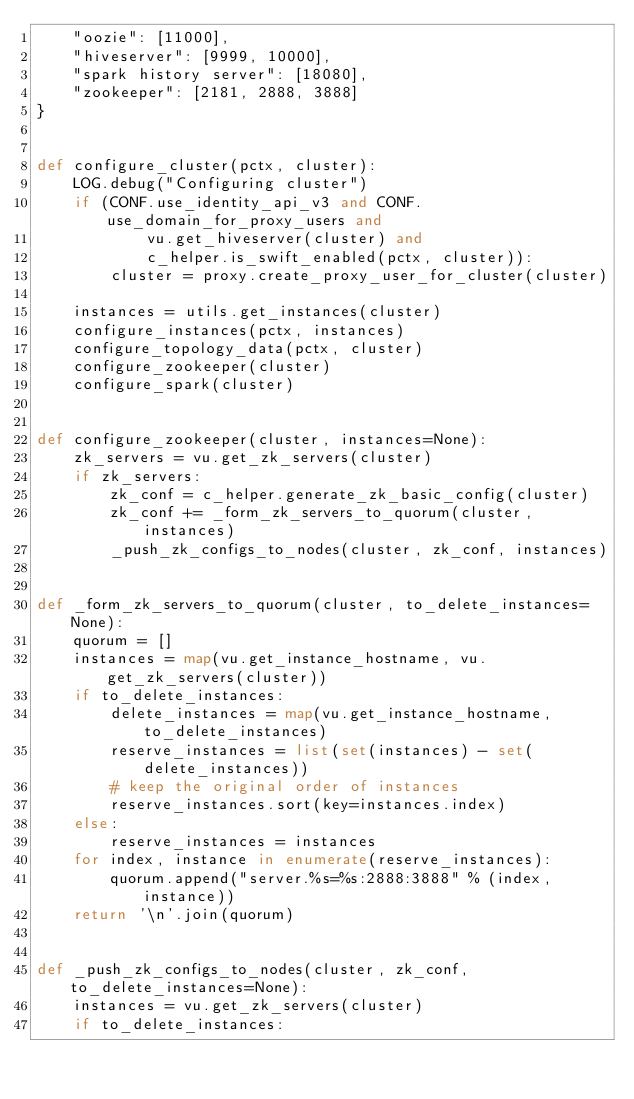Convert code to text. <code><loc_0><loc_0><loc_500><loc_500><_Python_>    "oozie": [11000],
    "hiveserver": [9999, 10000],
    "spark history server": [18080],
    "zookeeper": [2181, 2888, 3888]
}


def configure_cluster(pctx, cluster):
    LOG.debug("Configuring cluster")
    if (CONF.use_identity_api_v3 and CONF.use_domain_for_proxy_users and
            vu.get_hiveserver(cluster) and
            c_helper.is_swift_enabled(pctx, cluster)):
        cluster = proxy.create_proxy_user_for_cluster(cluster)

    instances = utils.get_instances(cluster)
    configure_instances(pctx, instances)
    configure_topology_data(pctx, cluster)
    configure_zookeeper(cluster)
    configure_spark(cluster)


def configure_zookeeper(cluster, instances=None):
    zk_servers = vu.get_zk_servers(cluster)
    if zk_servers:
        zk_conf = c_helper.generate_zk_basic_config(cluster)
        zk_conf += _form_zk_servers_to_quorum(cluster, instances)
        _push_zk_configs_to_nodes(cluster, zk_conf, instances)


def _form_zk_servers_to_quorum(cluster, to_delete_instances=None):
    quorum = []
    instances = map(vu.get_instance_hostname, vu.get_zk_servers(cluster))
    if to_delete_instances:
        delete_instances = map(vu.get_instance_hostname, to_delete_instances)
        reserve_instances = list(set(instances) - set(delete_instances))
        # keep the original order of instances
        reserve_instances.sort(key=instances.index)
    else:
        reserve_instances = instances
    for index, instance in enumerate(reserve_instances):
        quorum.append("server.%s=%s:2888:3888" % (index, instance))
    return '\n'.join(quorum)


def _push_zk_configs_to_nodes(cluster, zk_conf, to_delete_instances=None):
    instances = vu.get_zk_servers(cluster)
    if to_delete_instances:</code> 